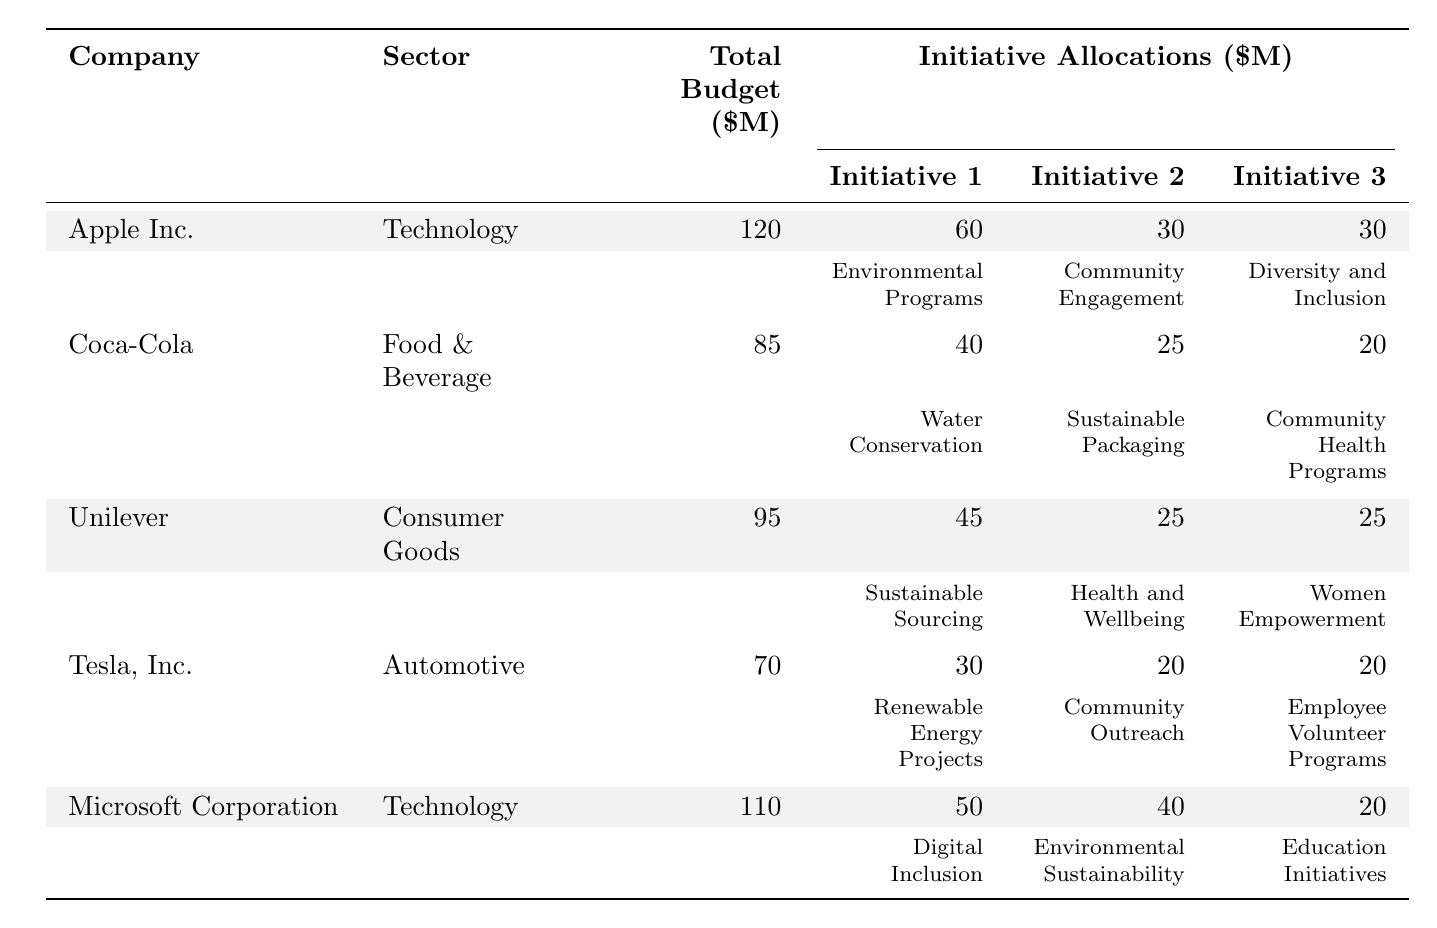What is the total budget allocated by Microsoft Corporation for CSR initiatives? The table shows that Microsoft Corporation has a total budget of 110 million dollars for CSR initiatives.
Answer: 110 million dollars Which company allocated the most money to environmental programs? Looking at the initiatives, Apple Inc. allocated 60 million to Environmental Programs, which is the highest among all companies listed.
Answer: Apple Inc What is the total amount allocated to community engagement initiatives across all companies? Calculating the community engagement initiatives: Apple Inc. 30 million + Coca-Cola 20 million + Tesla, Inc. 20 million = 70 million total.
Answer: 70 million Did Unilever allocate more to Sustainable Sourcing than to Health and Wellbeing? Unilever allocated 45 million to Sustainable Sourcing and 25 million to Health and Wellbeing. Therefore, the statement is true.
Answer: Yes What is the average budget allocation for the three major initiatives for Tesla, Inc.? The total allocation for Tesla's initiatives is 30 million + 20 million + 20 million = 70 million. Thus, the average is 70 million / 3 = approximately 23.33 million.
Answer: 23.33 million Which sector has a lower total budget, Food & Beverage or Automotive? The table shows Coca-Cola in Food & Beverage with 85 million and Tesla in Automotive with 70 million. Since 70 million is less than 85 million, the Automotive sector has a lower total budget.
Answer: Automotive If we compare the total budgets of Apple Inc. and Microsoft Corporation, how much more does Apple Inc. allocate? Apple Inc. has a budget of 120 million and Microsoft 110 million. Therefore, Apple Inc. allocates 120 million - 110 million = 10 million more.
Answer: 10 million Which company dedicated a higher percentage of its total budget to community health programs, Coca-Cola or Unilever? Coca-Cola allocated 20 million for Community Health Programs out of a total 85 million, making it 23.53% (20/85*100). Unilever did not have a community health program listed. Thus, Coca-Cola has a higher percentage.
Answer: Coca-Cola What is the total budget allocated for CSR initiatives by companies in the Technology sector? For Technology: Apple Inc. 120 million + Microsoft Corporation 110 million gives a total of 230 million.
Answer: 230 million Which company dedicated the least amount to diversity and inclusion initiatives? The table indicates that Tesla, Inc. allocated 20 million to its initiatives regarding community and employee engagement, which is less than the 30 million allocated by Apple and Unilever.
Answer: Tesla, Inc 